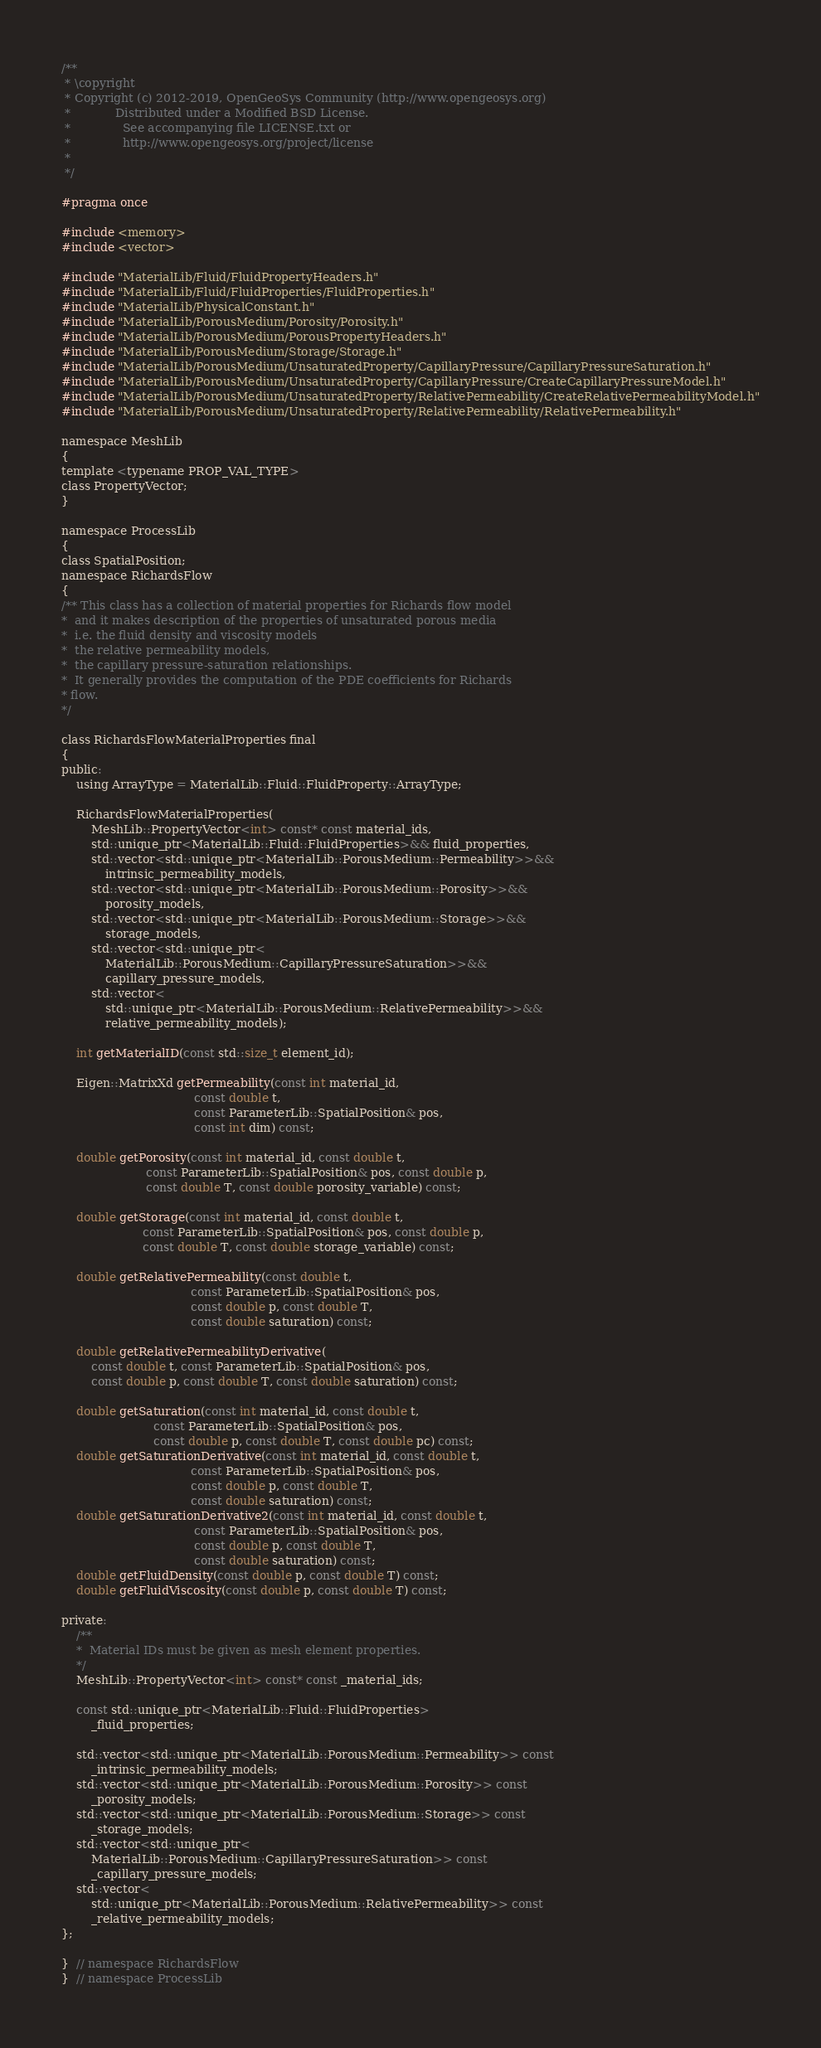<code> <loc_0><loc_0><loc_500><loc_500><_C_>/**
 * \copyright
 * Copyright (c) 2012-2019, OpenGeoSys Community (http://www.opengeosys.org)
 *            Distributed under a Modified BSD License.
 *              See accompanying file LICENSE.txt or
 *              http://www.opengeosys.org/project/license
 *
 */

#pragma once

#include <memory>
#include <vector>

#include "MaterialLib/Fluid/FluidPropertyHeaders.h"
#include "MaterialLib/Fluid/FluidProperties/FluidProperties.h"
#include "MaterialLib/PhysicalConstant.h"
#include "MaterialLib/PorousMedium/Porosity/Porosity.h"
#include "MaterialLib/PorousMedium/PorousPropertyHeaders.h"
#include "MaterialLib/PorousMedium/Storage/Storage.h"
#include "MaterialLib/PorousMedium/UnsaturatedProperty/CapillaryPressure/CapillaryPressureSaturation.h"
#include "MaterialLib/PorousMedium/UnsaturatedProperty/CapillaryPressure/CreateCapillaryPressureModel.h"
#include "MaterialLib/PorousMedium/UnsaturatedProperty/RelativePermeability/CreateRelativePermeabilityModel.h"
#include "MaterialLib/PorousMedium/UnsaturatedProperty/RelativePermeability/RelativePermeability.h"

namespace MeshLib
{
template <typename PROP_VAL_TYPE>
class PropertyVector;
}

namespace ProcessLib
{
class SpatialPosition;
namespace RichardsFlow
{
/** This class has a collection of material properties for Richards flow model
*  and it makes description of the properties of unsaturated porous media
*  i.e. the fluid density and viscosity models
*  the relative permeability models,
*  the capillary pressure-saturation relationships.
*  It generally provides the computation of the PDE coefficients for Richards
* flow.
*/

class RichardsFlowMaterialProperties final
{
public:
    using ArrayType = MaterialLib::Fluid::FluidProperty::ArrayType;

    RichardsFlowMaterialProperties(
        MeshLib::PropertyVector<int> const* const material_ids,
        std::unique_ptr<MaterialLib::Fluid::FluidProperties>&& fluid_properties,
        std::vector<std::unique_ptr<MaterialLib::PorousMedium::Permeability>>&&
            intrinsic_permeability_models,
        std::vector<std::unique_ptr<MaterialLib::PorousMedium::Porosity>>&&
            porosity_models,
        std::vector<std::unique_ptr<MaterialLib::PorousMedium::Storage>>&&
            storage_models,
        std::vector<std::unique_ptr<
            MaterialLib::PorousMedium::CapillaryPressureSaturation>>&&
            capillary_pressure_models,
        std::vector<
            std::unique_ptr<MaterialLib::PorousMedium::RelativePermeability>>&&
            relative_permeability_models);

    int getMaterialID(const std::size_t element_id);

    Eigen::MatrixXd getPermeability(const int material_id,
                                    const double t,
                                    const ParameterLib::SpatialPosition& pos,
                                    const int dim) const;

    double getPorosity(const int material_id, const double t,
                       const ParameterLib::SpatialPosition& pos, const double p,
                       const double T, const double porosity_variable) const;

    double getStorage(const int material_id, const double t,
                      const ParameterLib::SpatialPosition& pos, const double p,
                      const double T, const double storage_variable) const;

    double getRelativePermeability(const double t,
                                   const ParameterLib::SpatialPosition& pos,
                                   const double p, const double T,
                                   const double saturation) const;

    double getRelativePermeabilityDerivative(
        const double t, const ParameterLib::SpatialPosition& pos,
        const double p, const double T, const double saturation) const;

    double getSaturation(const int material_id, const double t,
                         const ParameterLib::SpatialPosition& pos,
                         const double p, const double T, const double pc) const;
    double getSaturationDerivative(const int material_id, const double t,
                                   const ParameterLib::SpatialPosition& pos,
                                   const double p, const double T,
                                   const double saturation) const;
    double getSaturationDerivative2(const int material_id, const double t,
                                    const ParameterLib::SpatialPosition& pos,
                                    const double p, const double T,
                                    const double saturation) const;
    double getFluidDensity(const double p, const double T) const;
    double getFluidViscosity(const double p, const double T) const;

private:
    /**
    *  Material IDs must be given as mesh element properties.
    */
    MeshLib::PropertyVector<int> const* const _material_ids;

    const std::unique_ptr<MaterialLib::Fluid::FluidProperties>
        _fluid_properties;

    std::vector<std::unique_ptr<MaterialLib::PorousMedium::Permeability>> const
        _intrinsic_permeability_models;
    std::vector<std::unique_ptr<MaterialLib::PorousMedium::Porosity>> const
        _porosity_models;
    std::vector<std::unique_ptr<MaterialLib::PorousMedium::Storage>> const
        _storage_models;
    std::vector<std::unique_ptr<
        MaterialLib::PorousMedium::CapillaryPressureSaturation>> const
        _capillary_pressure_models;
    std::vector<
        std::unique_ptr<MaterialLib::PorousMedium::RelativePermeability>> const
        _relative_permeability_models;
};

}  // namespace RichardsFlow
}  // namespace ProcessLib
</code> 